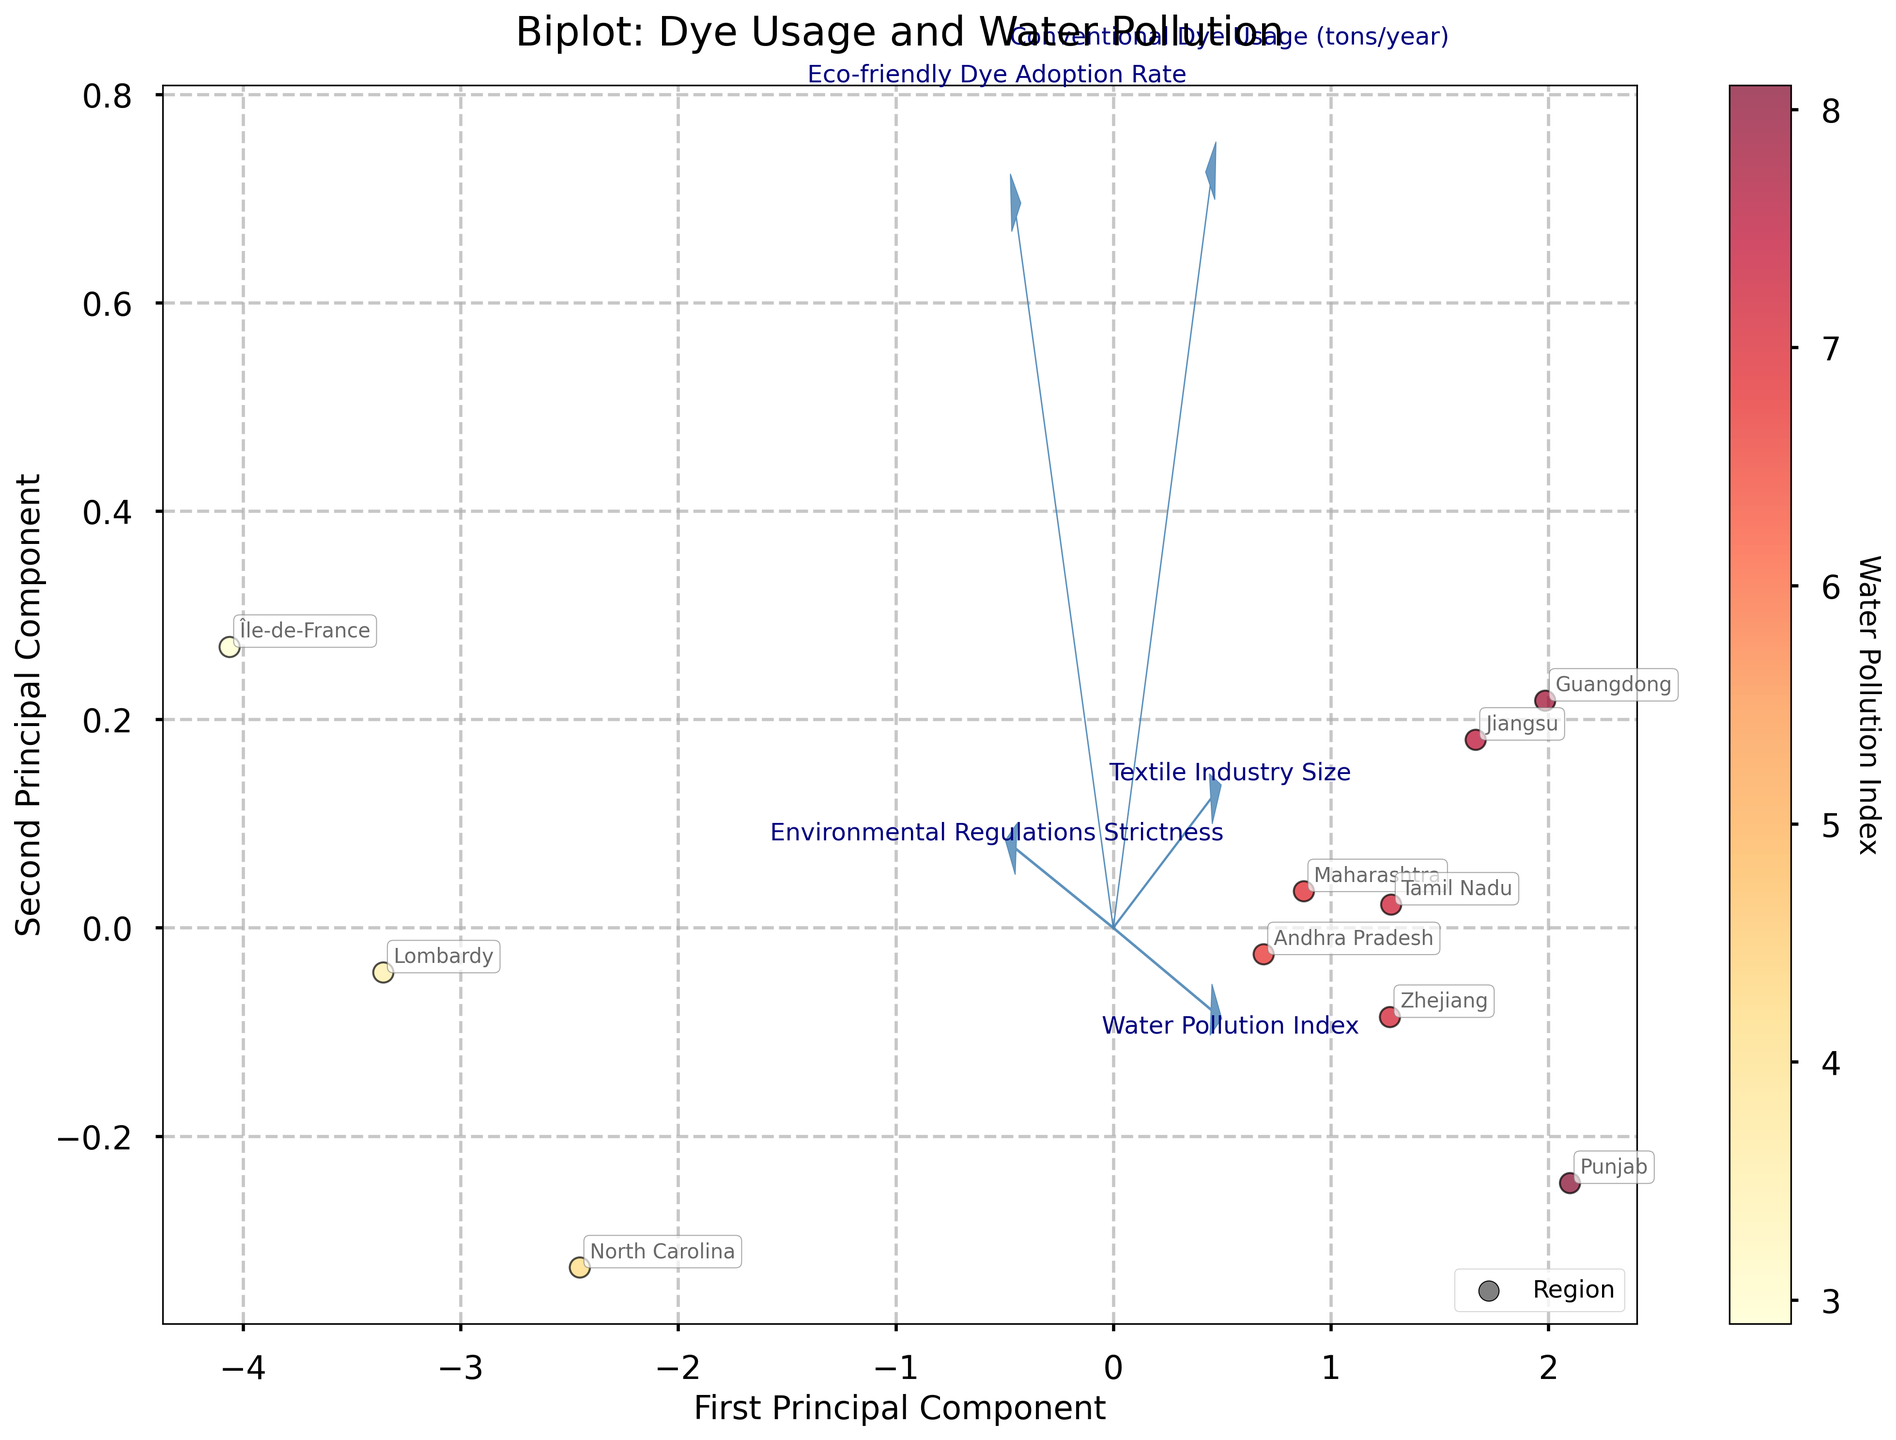How many regions are shown in the biplot? Count the number of data points (regions) plotted in the biplot.
Answer: 10 Which region has the highest Water Pollution Index? Look for the region with the darkest color (as color intensity represents Water Pollution Index). Track the color bar's highest value to the corresponding point.
Answer: Punjab What is the relationship between Textile Industry Size and Conventional Dye Usage? Examine the direction and length of the feature vectors for 'Textile Industry Size' and 'Conventional Dye Usage'. Both vectors point in a similar direction, indicating a positive correlation.
Answer: Positive correlation Is there a region with high Environmental Regulations Strictness and low Conventional Dye Usage? Look for regions plotted close to the vector of 'Environmental Regulations Strictness' and far from the vector of 'Conventional Dye Usage'.
Answer: Île-de-France Which principal component explains more variance? Check the axis labels of the biplot to see which axis (First Principal Component or Second Principal Component) has a greater value.
Answer: First Principal Component How does Eco-friendly Dye Adoption Rate correlate with Water Pollution Index? Observe the direction of the feature vectors for 'Eco-friendly Dye Adoption Rate' and 'Water Pollution Index'. They point in opposite directions, indicating a negative correlation.
Answer: Negative correlation Compare the regions Maharashtra and Jiangsu based on their PCA coordinates. Which region is plotted further to the right? Compare the x-coordinates of the points representing Maharashtra and Jiangsu. The region with the greater x-coordinate is plotted further to the right.
Answer: Jiangsu Do regions with smaller Textile Industry Size typically have lower Water Pollution Index? Inspect the positions of regions relative to the vectors for 'Textile Industry Size' and 'Water Pollution Index'. Regions with smaller Textile Industry Size are on the left side, which also generally have lower Water Pollution Index.
Answer: Yes How does the vector direction of 'Environmental Regulations Strictness' compare with the direction of 'Water Pollution Index'? Analyze the directions of the vectors for 'Environmental Regulations Strictness' and 'Water Pollution Index'. They point in opposite directions, indicating an antagonistic relationship.
Answer: Opposite directions Which region demonstrates a higher Eco-friendly Dye Adoption Rate, Maharashtra or Tamil Nadu? Locate the regions Maharashtra and Tamil Nadu and examine their positions relative to the 'Eco-friendly Dye Adoption Rate' vector. The one closer to the direction of the vector has a higher adoption rate.
Answer: Maharashtra 